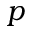Convert formula to latex. <formula><loc_0><loc_0><loc_500><loc_500>p</formula> 